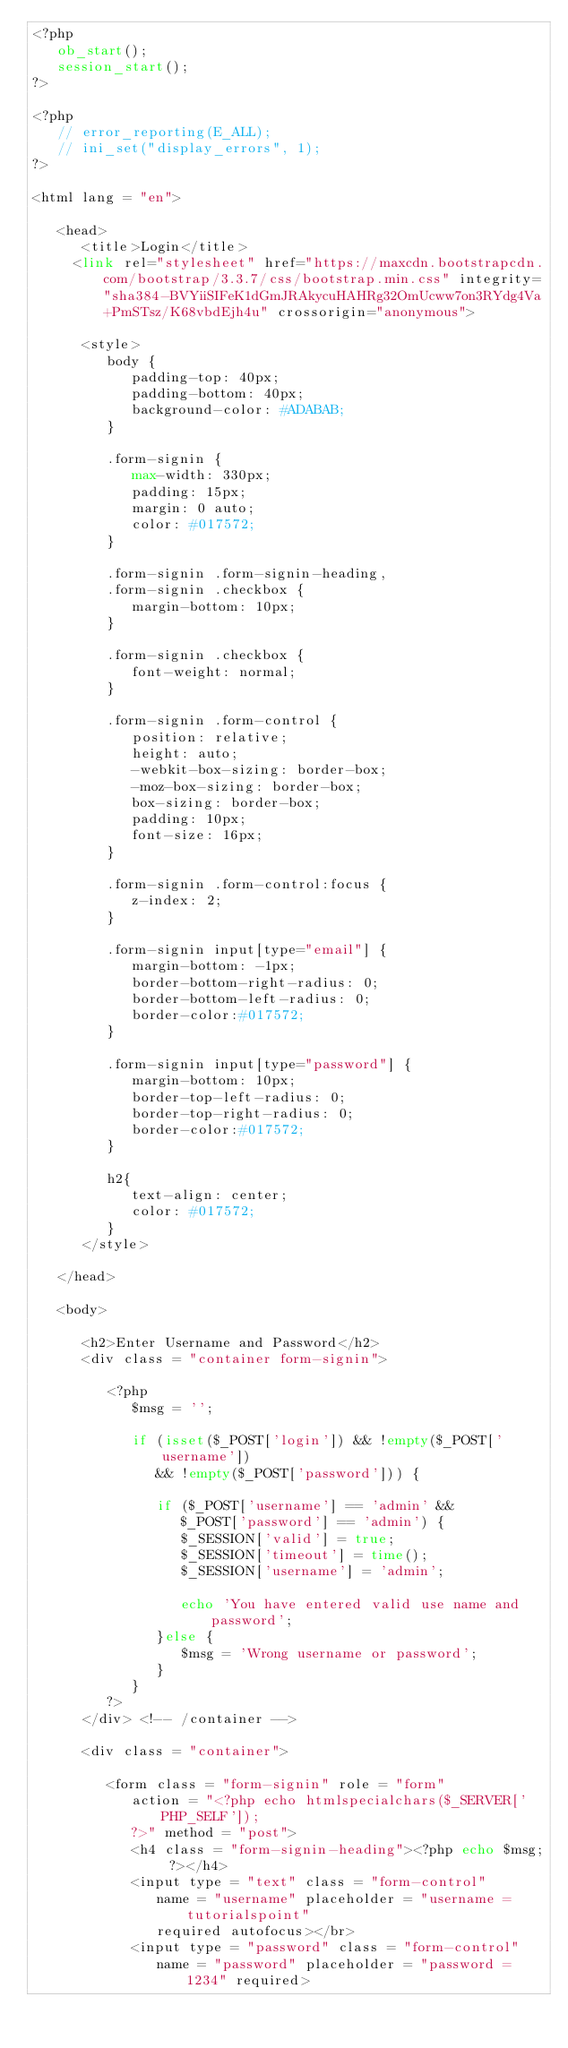Convert code to text. <code><loc_0><loc_0><loc_500><loc_500><_PHP_><?php
   ob_start();
   session_start();
?>

<?php
   // error_reporting(E_ALL);
   // ini_set("display_errors", 1);
?>

<html lang = "en">
   
   <head>
      <title>Login</title>
     <link rel="stylesheet" href="https://maxcdn.bootstrapcdn.com/bootstrap/3.3.7/css/bootstrap.min.css" integrity="sha384-BVYiiSIFeK1dGmJRAkycuHAHRg32OmUcww7on3RYdg4Va+PmSTsz/K68vbdEjh4u" crossorigin="anonymous">
      
      <style>
         body {
            padding-top: 40px;
            padding-bottom: 40px;
            background-color: #ADABAB;
         }
         
         .form-signin {
            max-width: 330px;
            padding: 15px;
            margin: 0 auto;
            color: #017572;
         }
         
         .form-signin .form-signin-heading,
         .form-signin .checkbox {
            margin-bottom: 10px;
         }
         
         .form-signin .checkbox {
            font-weight: normal;
         }
         
         .form-signin .form-control {
            position: relative;
            height: auto;
            -webkit-box-sizing: border-box;
            -moz-box-sizing: border-box;
            box-sizing: border-box;
            padding: 10px;
            font-size: 16px;
         }
         
         .form-signin .form-control:focus {
            z-index: 2;
         }
         
         .form-signin input[type="email"] {
            margin-bottom: -1px;
            border-bottom-right-radius: 0;
            border-bottom-left-radius: 0;
            border-color:#017572;
         }
         
         .form-signin input[type="password"] {
            margin-bottom: 10px;
            border-top-left-radius: 0;
            border-top-right-radius: 0;
            border-color:#017572;
         }
         
         h2{
            text-align: center;
            color: #017572;
         }
      </style>
      
   </head>
	
   <body>
      
      <h2>Enter Username and Password</h2> 
      <div class = "container form-signin">
         
         <?php
            $msg = '';
            
            if (isset($_POST['login']) && !empty($_POST['username']) 
               && !empty($_POST['password'])) {
				
               if ($_POST['username'] == 'admin' && 
                  $_POST['password'] == 'admin') {
                  $_SESSION['valid'] = true;
                  $_SESSION['timeout'] = time();
                  $_SESSION['username'] = 'admin';
                  
                  echo 'You have entered valid use name and password';
               }else {
                  $msg = 'Wrong username or password';
               }
            }
         ?>
      </div> <!-- /container -->
      
      <div class = "container">
      
         <form class = "form-signin" role = "form" 
            action = "<?php echo htmlspecialchars($_SERVER['PHP_SELF']); 
            ?>" method = "post">
            <h4 class = "form-signin-heading"><?php echo $msg; ?></h4>
            <input type = "text" class = "form-control" 
               name = "username" placeholder = "username = tutorialspoint" 
               required autofocus></br>
            <input type = "password" class = "form-control"
               name = "password" placeholder = "password = 1234" required></code> 